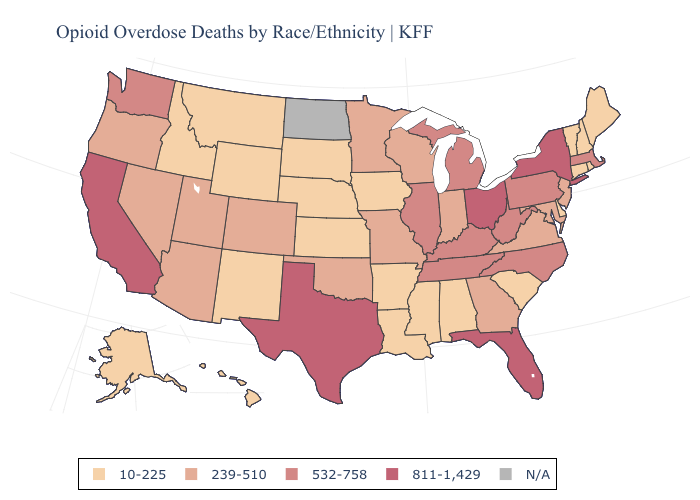Does the map have missing data?
Give a very brief answer. Yes. What is the value of Montana?
Concise answer only. 10-225. Among the states that border Michigan , does Wisconsin have the lowest value?
Give a very brief answer. Yes. Does South Dakota have the lowest value in the MidWest?
Quick response, please. Yes. Does Maryland have the highest value in the USA?
Give a very brief answer. No. What is the value of Alabama?
Write a very short answer. 10-225. Does New York have the highest value in the Northeast?
Short answer required. Yes. Does California have the highest value in the USA?
Answer briefly. Yes. What is the value of Utah?
Answer briefly. 239-510. Is the legend a continuous bar?
Answer briefly. No. What is the value of California?
Write a very short answer. 811-1,429. What is the value of Oklahoma?
Short answer required. 239-510. Does West Virginia have the lowest value in the USA?
Quick response, please. No. What is the lowest value in the MidWest?
Write a very short answer. 10-225. Name the states that have a value in the range 239-510?
Answer briefly. Arizona, Colorado, Georgia, Indiana, Maryland, Minnesota, Missouri, Nevada, New Jersey, Oklahoma, Oregon, Utah, Virginia, Wisconsin. 